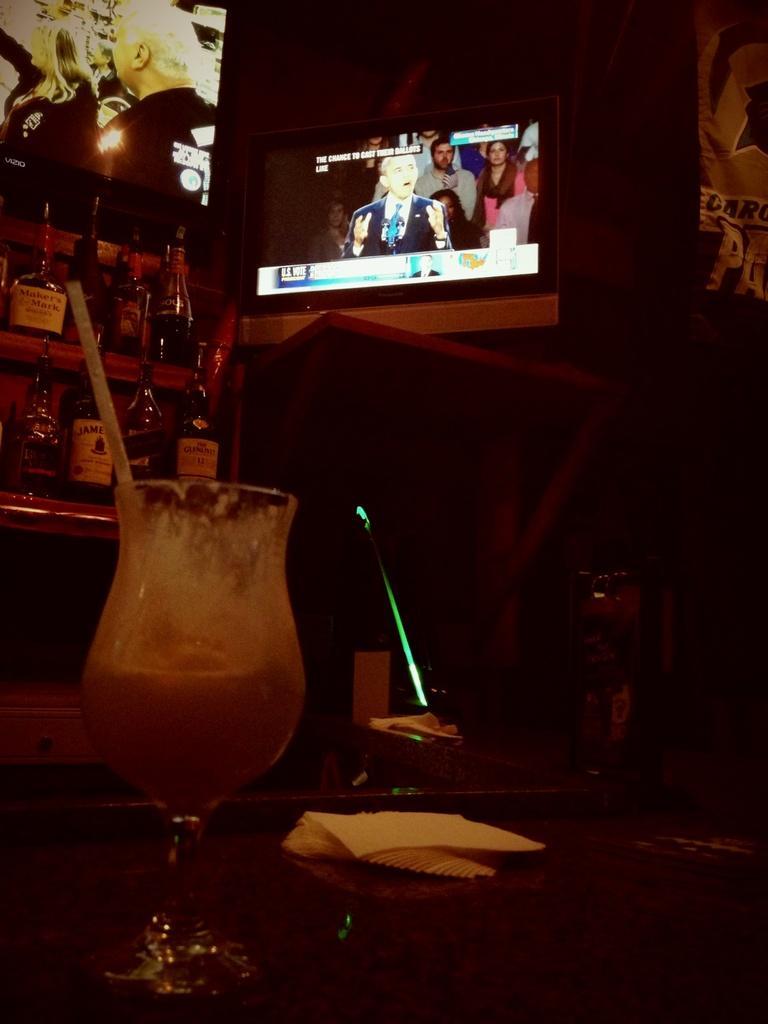In one or two sentences, can you explain what this image depicts? At the bottom of the image there is a table. On the table there is a glass and tissues. In the background there is a shelf and there are bottles placed in the shelves. On the right there is a television which is attached to the wall. 